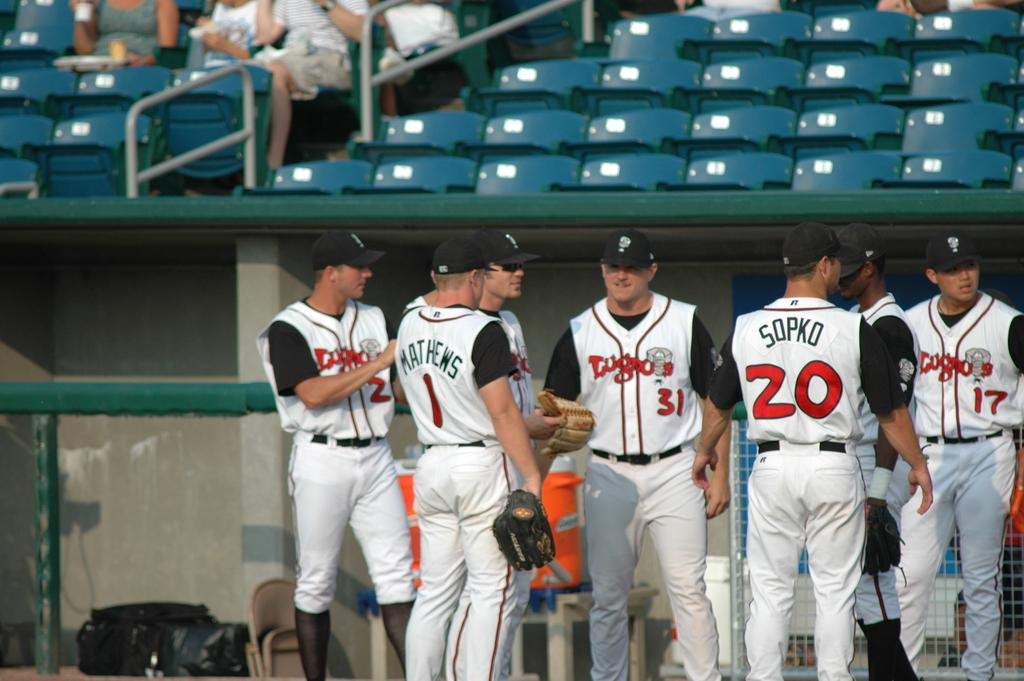<image>
Give a short and clear explanation of the subsequent image. Part of a baseball team standing on the field in a stadium with their names and numbers on the back of their shirt like Matthews 1 and Sopko 20. 